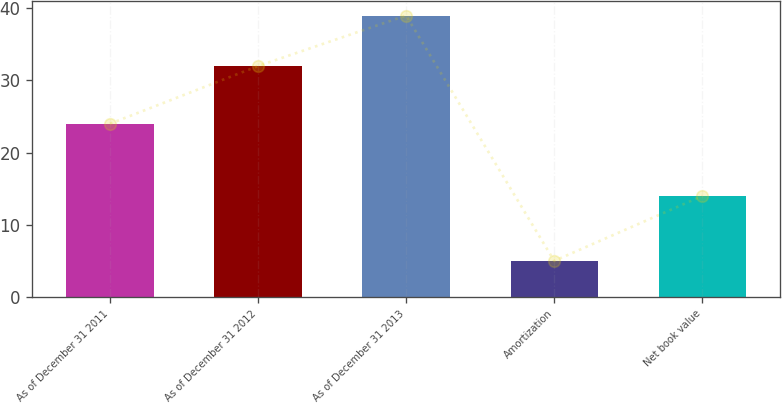Convert chart to OTSL. <chart><loc_0><loc_0><loc_500><loc_500><bar_chart><fcel>As of December 31 2011<fcel>As of December 31 2012<fcel>As of December 31 2013<fcel>Amortization<fcel>Net book value<nl><fcel>24<fcel>32<fcel>39<fcel>5<fcel>14<nl></chart> 